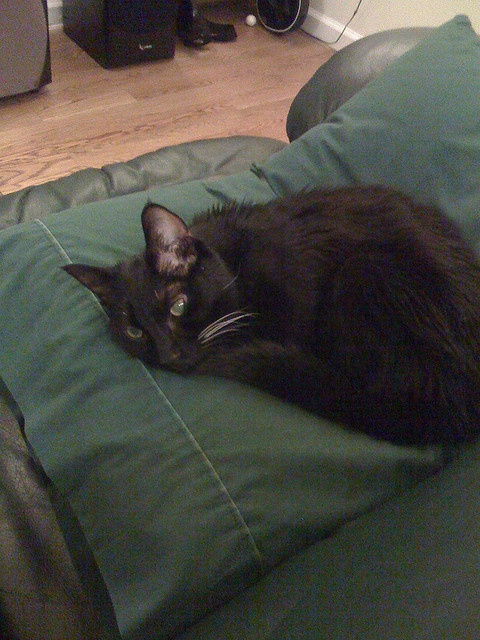Describe the objects in this image and their specific colors. I can see chair in black, gray, and darkgreen tones and cat in gray and black tones in this image. 